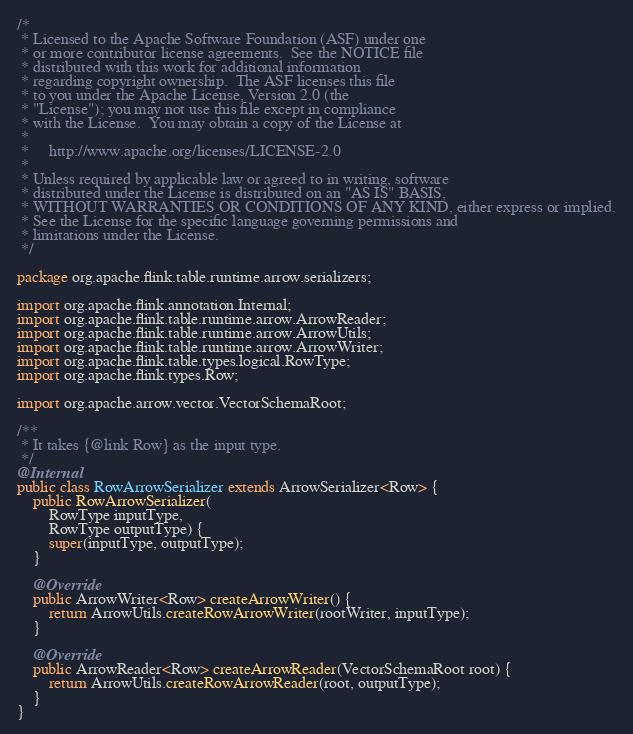<code> <loc_0><loc_0><loc_500><loc_500><_Java_>/*
 * Licensed to the Apache Software Foundation (ASF) under one
 * or more contributor license agreements.  See the NOTICE file
 * distributed with this work for additional information
 * regarding copyright ownership.  The ASF licenses this file
 * to you under the Apache License, Version 2.0 (the
 * "License"); you may not use this file except in compliance
 * with the License.  You may obtain a copy of the License at
 *
 *     http://www.apache.org/licenses/LICENSE-2.0
 *
 * Unless required by applicable law or agreed to in writing, software
 * distributed under the License is distributed on an "AS IS" BASIS,
 * WITHOUT WARRANTIES OR CONDITIONS OF ANY KIND, either express or implied.
 * See the License for the specific language governing permissions and
 * limitations under the License.
 */

package org.apache.flink.table.runtime.arrow.serializers;

import org.apache.flink.annotation.Internal;
import org.apache.flink.table.runtime.arrow.ArrowReader;
import org.apache.flink.table.runtime.arrow.ArrowUtils;
import org.apache.flink.table.runtime.arrow.ArrowWriter;
import org.apache.flink.table.types.logical.RowType;
import org.apache.flink.types.Row;

import org.apache.arrow.vector.VectorSchemaRoot;

/**
 * It takes {@link Row} as the input type.
 */
@Internal
public class RowArrowSerializer extends ArrowSerializer<Row> {
	public RowArrowSerializer(
		RowType inputType,
		RowType outputType) {
		super(inputType, outputType);
	}

	@Override
	public ArrowWriter<Row> createArrowWriter() {
		return ArrowUtils.createRowArrowWriter(rootWriter, inputType);
	}

	@Override
	public ArrowReader<Row> createArrowReader(VectorSchemaRoot root) {
		return ArrowUtils.createRowArrowReader(root, outputType);
	}
}
</code> 